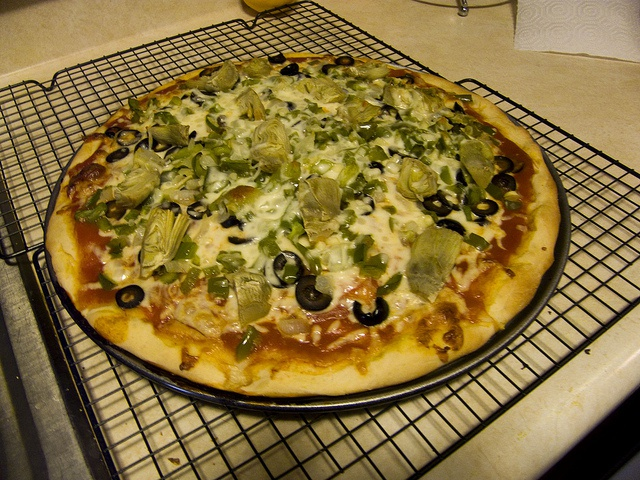Describe the objects in this image and their specific colors. I can see a pizza in black, olive, and tan tones in this image. 